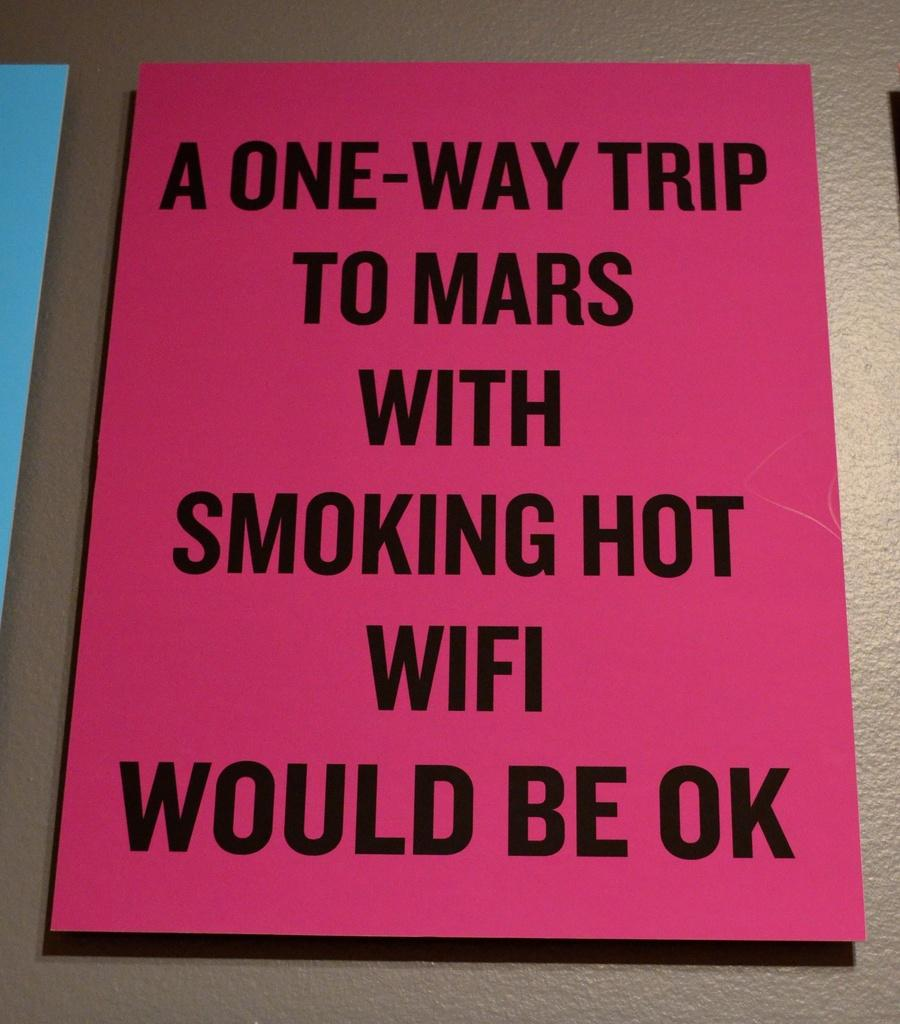<image>
Provide a brief description of the given image. Some people would like to move to Mars, as long as there is Wifi. 